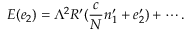Convert formula to latex. <formula><loc_0><loc_0><loc_500><loc_500>E ( e _ { 2 } ) = \Lambda ^ { 2 } R ^ { \prime } ( \frac { c } { N } n _ { 1 } ^ { \prime } + { e } _ { 2 } ^ { \prime } ) + \cdots .</formula> 